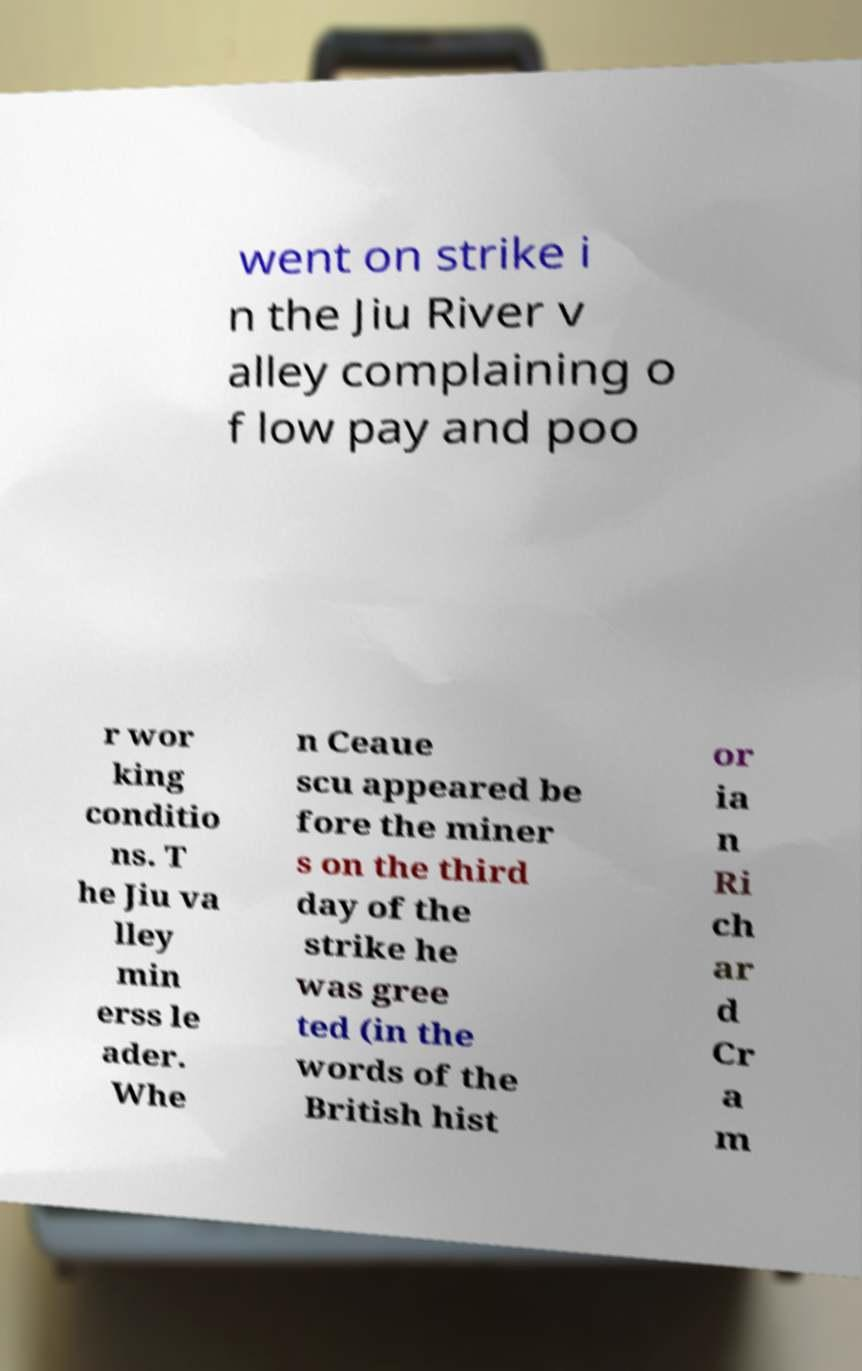Please read and relay the text visible in this image. What does it say? went on strike i n the Jiu River v alley complaining o f low pay and poo r wor king conditio ns. T he Jiu va lley min erss le ader. Whe n Ceaue scu appeared be fore the miner s on the third day of the strike he was gree ted (in the words of the British hist or ia n Ri ch ar d Cr a m 